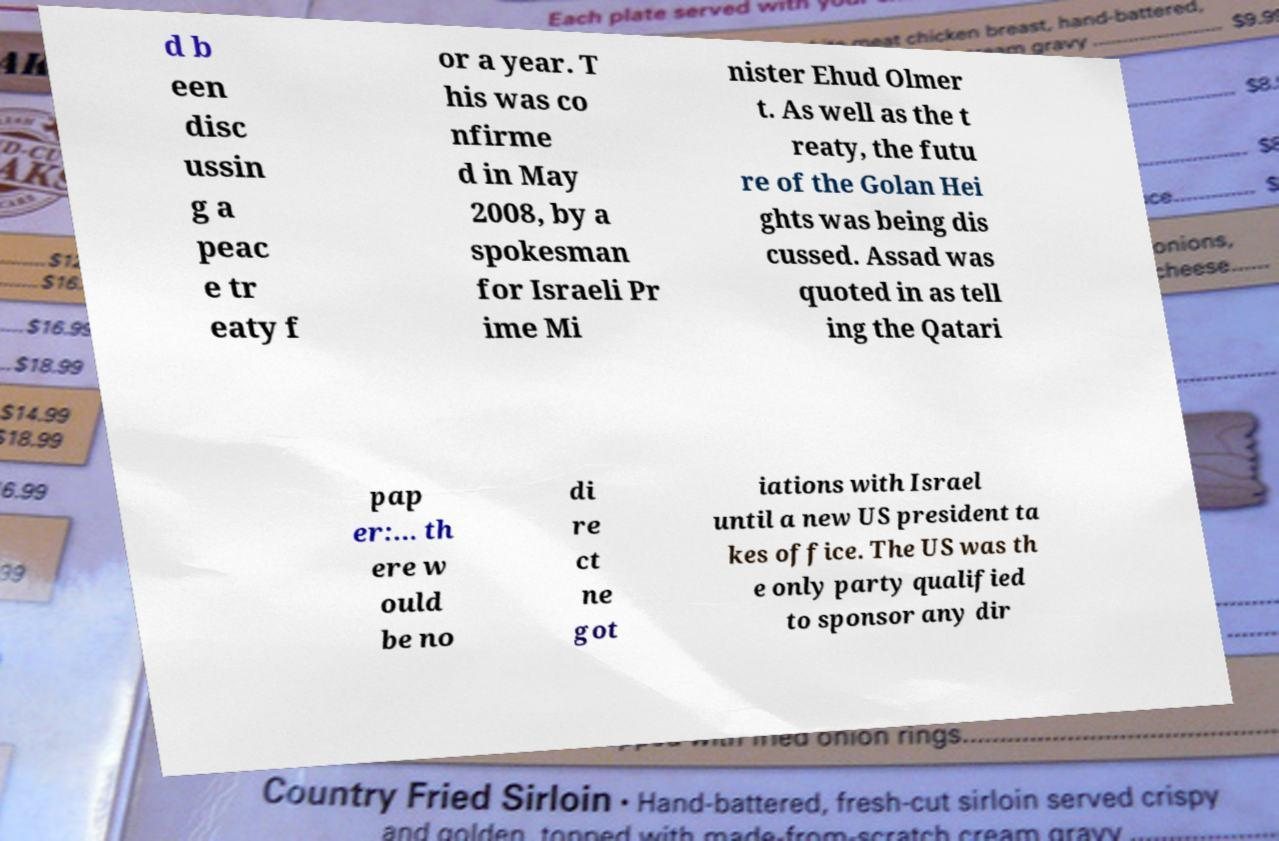There's text embedded in this image that I need extracted. Can you transcribe it verbatim? d b een disc ussin g a peac e tr eaty f or a year. T his was co nfirme d in May 2008, by a spokesman for Israeli Pr ime Mi nister Ehud Olmer t. As well as the t reaty, the futu re of the Golan Hei ghts was being dis cussed. Assad was quoted in as tell ing the Qatari pap er:... th ere w ould be no di re ct ne got iations with Israel until a new US president ta kes office. The US was th e only party qualified to sponsor any dir 